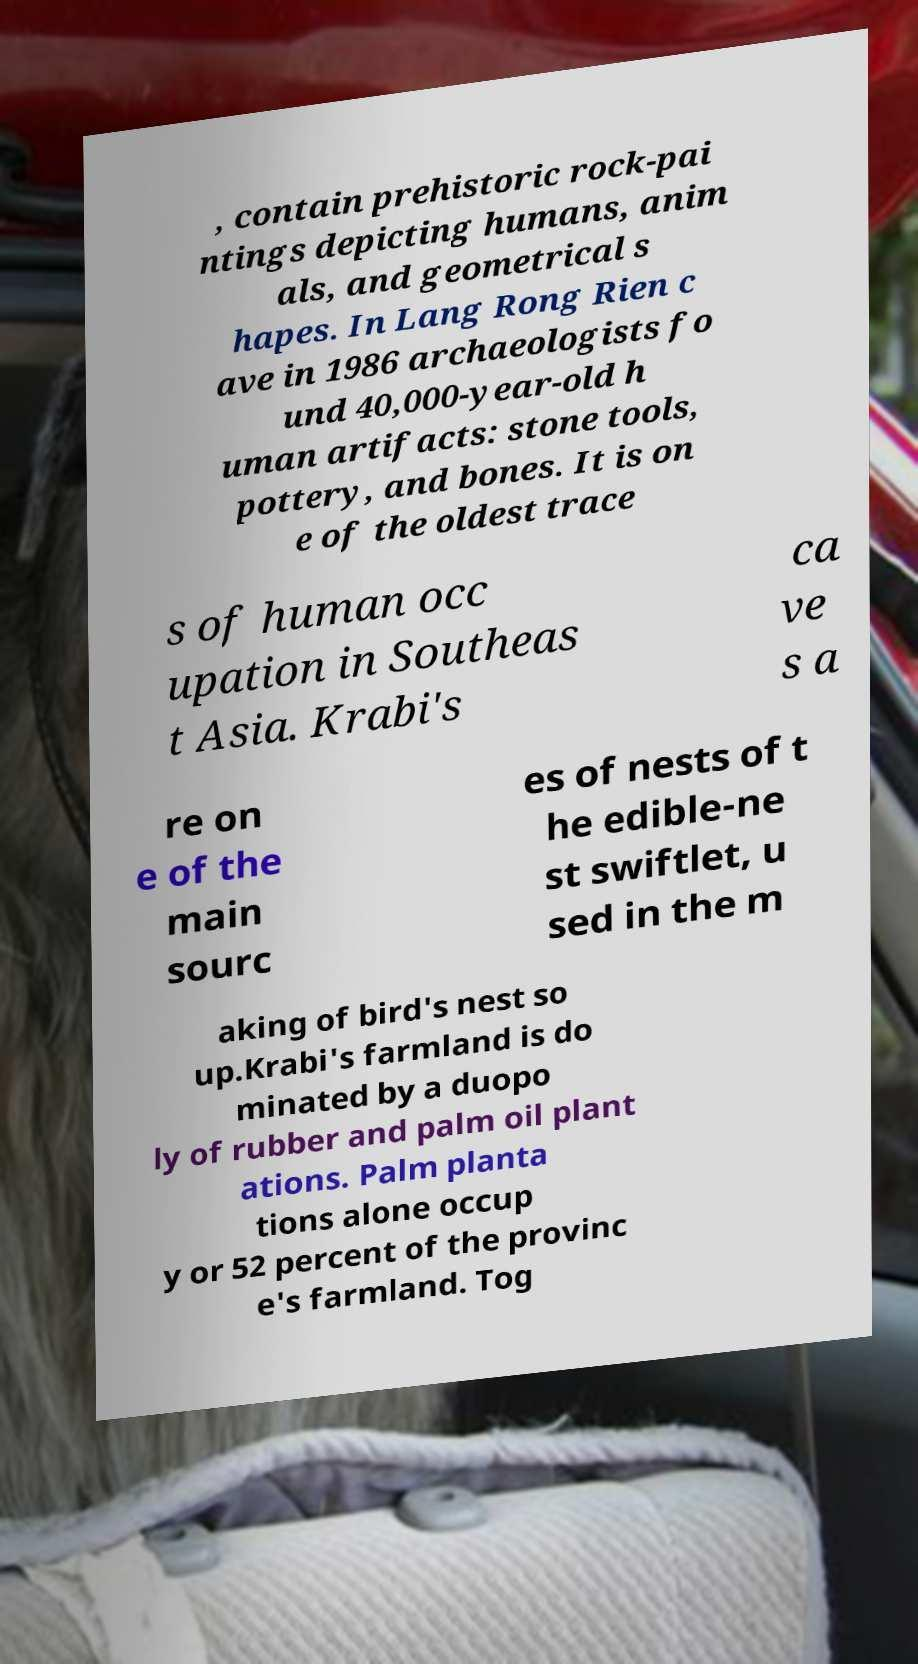Could you extract and type out the text from this image? , contain prehistoric rock-pai ntings depicting humans, anim als, and geometrical s hapes. In Lang Rong Rien c ave in 1986 archaeologists fo und 40,000-year-old h uman artifacts: stone tools, pottery, and bones. It is on e of the oldest trace s of human occ upation in Southeas t Asia. Krabi's ca ve s a re on e of the main sourc es of nests of t he edible-ne st swiftlet, u sed in the m aking of bird's nest so up.Krabi's farmland is do minated by a duopo ly of rubber and palm oil plant ations. Palm planta tions alone occup y or 52 percent of the provinc e's farmland. Tog 